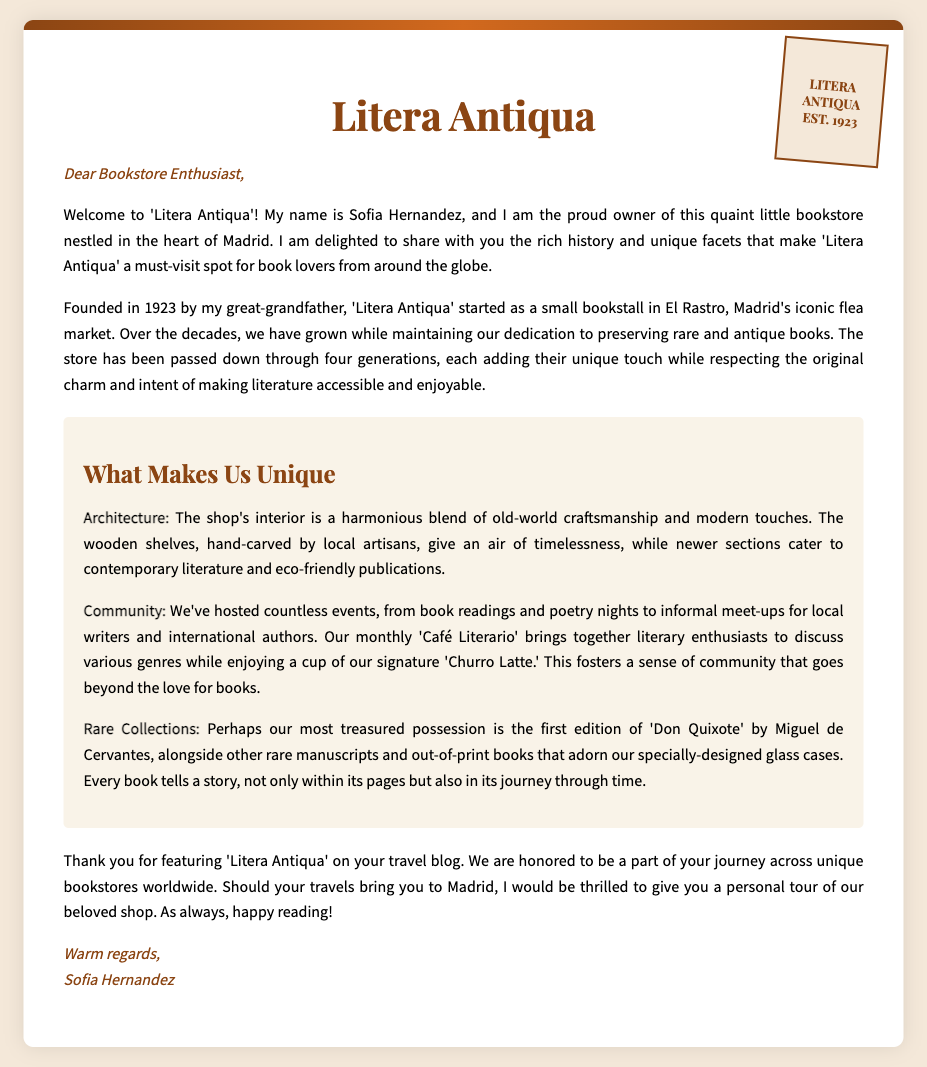What is the name of the bookstore? The name of the bookstore is mentioned in the document as 'Litera Antiqua'.
Answer: Litera Antiqua Who is the owner of the bookstore? The owner's name is provided in the letter; she introduces herself as Sofia Hernandez.
Answer: Sofia Hernandez In which city is Litera Antiqua located? The location of the bookstore is specified in the letter as being in the heart of Madrid.
Answer: Madrid When was Litera Antiqua founded? The document states that the bookstore was founded in the year 1923.
Answer: 1923 What is a unique architectural feature of the bookstore? The letter describes the wooden shelves as being hand-carved by local artisans, highlighting a specific architectural feature.
Answer: Hand-carved wooden shelves What kind of events does the bookstore host? The document mentions hosting book readings, poetry nights, and a 'Café Literario'.
Answer: Book readings and poetry nights What is the title of a rare book mentioned in the letter? The document references a first edition of 'Don Quixote' by Miguel de Cervantes as a rare book.
Answer: Don Quixote What drink is specifically mentioned in connection with the bookstore’s events? The letter mentions a signature drink, the 'Churro Latte', associated with their literary community events.
Answer: Churro Latte How many generations has the bookstore been passed down through? The document states that the bookstore has been passed down through four generations.
Answer: Four generations 